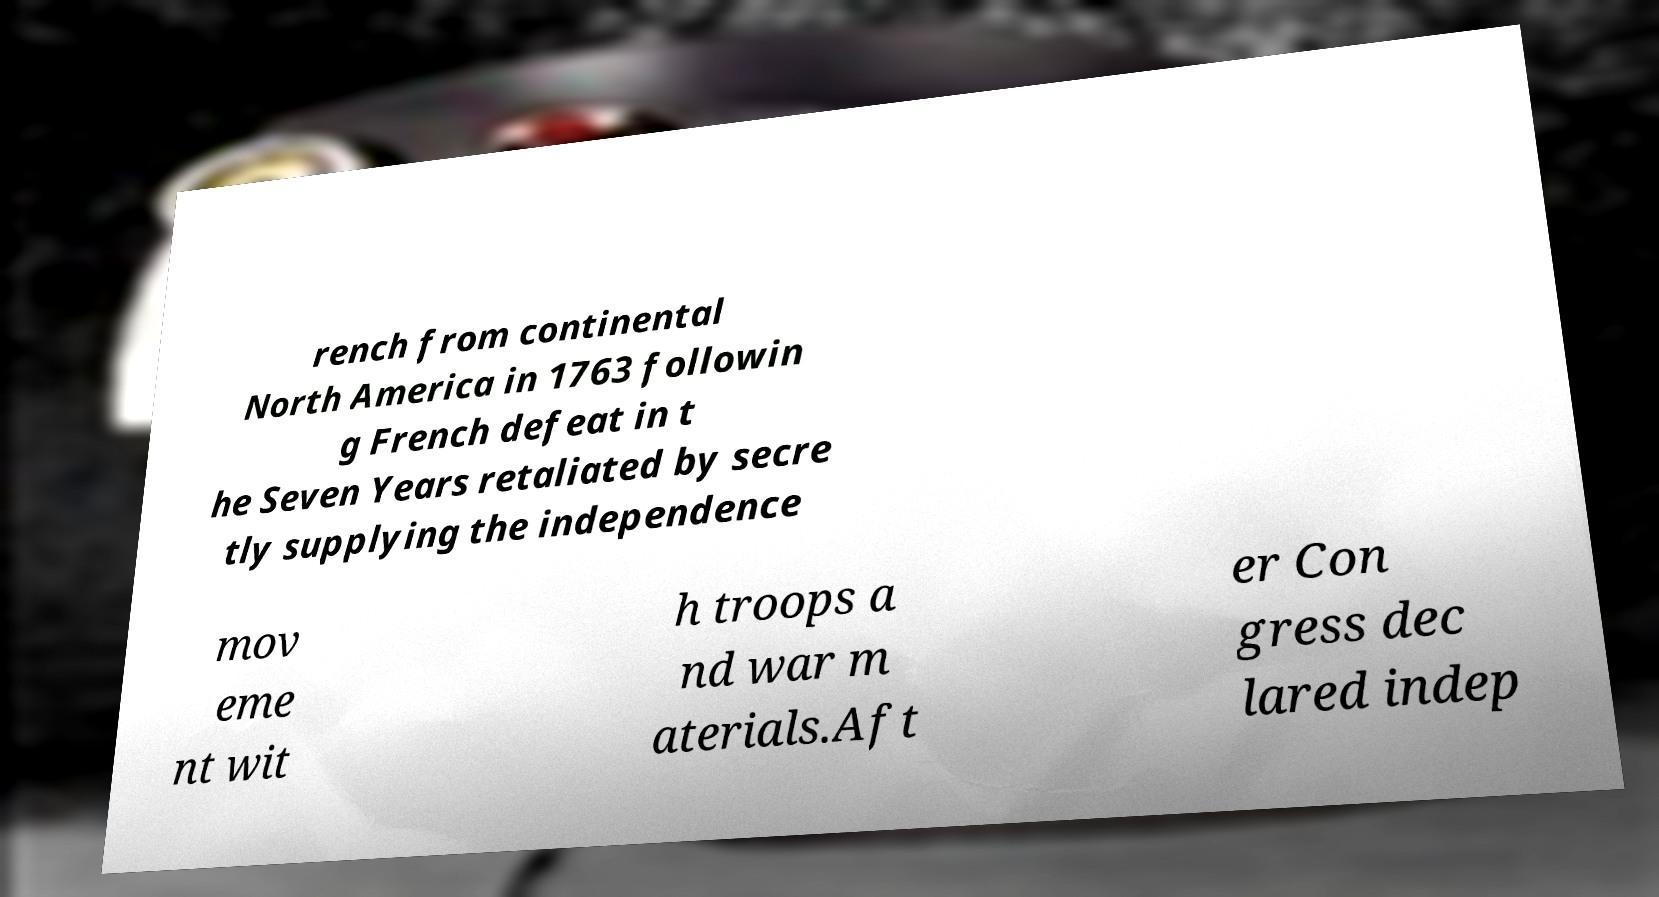Can you read and provide the text displayed in the image?This photo seems to have some interesting text. Can you extract and type it out for me? rench from continental North America in 1763 followin g French defeat in t he Seven Years retaliated by secre tly supplying the independence mov eme nt wit h troops a nd war m aterials.Aft er Con gress dec lared indep 